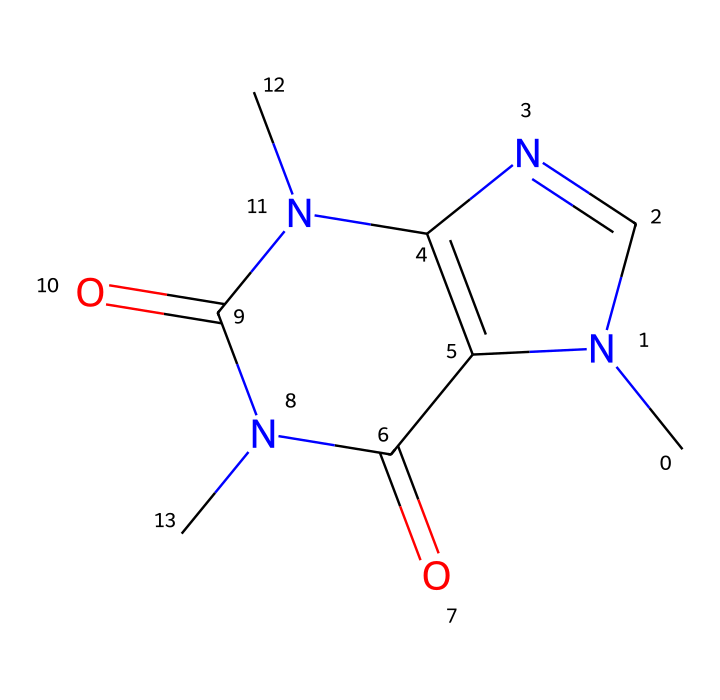What is the molecular formula of caffeine? To determine the molecular formula, count the number of each type of atom in the structure provided. The molecular formula for caffeine is derived from its constituent atoms: 8 carbon (C), 10 hydrogen (H), 4 nitrogen (N), and 2 oxygen (O) atoms. Therefore, the formula is C8H10N4O2.
Answer: C8H10N4O2 How many rings are present in the caffeine structure? By examining the structure, we can identify that caffeine consists of two fused rings. The rings are a pyrimidine and an imidazole, which are both heterocyclic compounds containing nitrogen atoms. Fusing these rings is typical in many alkaloids, and here we specifically have two rings in caffeine.
Answer: 2 What type of compound is caffeine classified as? Caffeine is classified as an alkaloid, which is a class of nitrogen-containing organic compounds that are often derived from plant sources. In the structure, the presence of multiple nitrogen atoms signifies its classification as an alkaloid.
Answer: alkaloid How many nitrogen atoms are found in caffeine? In the provided chemical structure, by counting the visible nitrogen atoms, it is apparent that there are four nitrogen atoms present in the caffeine molecule. These nitrogen atoms play a significant role in the biological activity of caffeine.
Answer: 4 What functional groups are present in caffeine? To identify the functional groups, we need to analyze the structure closely. There are carbonyl groups (C=O), which are characteristic of amides present in the structure of caffeine. Identifying these groups confirms the presence of amide functional groups in the caffeine molecule.
Answer: amide Which part of caffeine contributes to its stimulating effects? The nitrogen atoms located in the structure contribute to caffeine's ability to stimulate the central nervous system. Specifically, the arrangement of the nitrogen atoms allows caffeine to interact with adenosine receptors, leading to increased alertness and reduced fatigue.
Answer: nitrogen atoms 